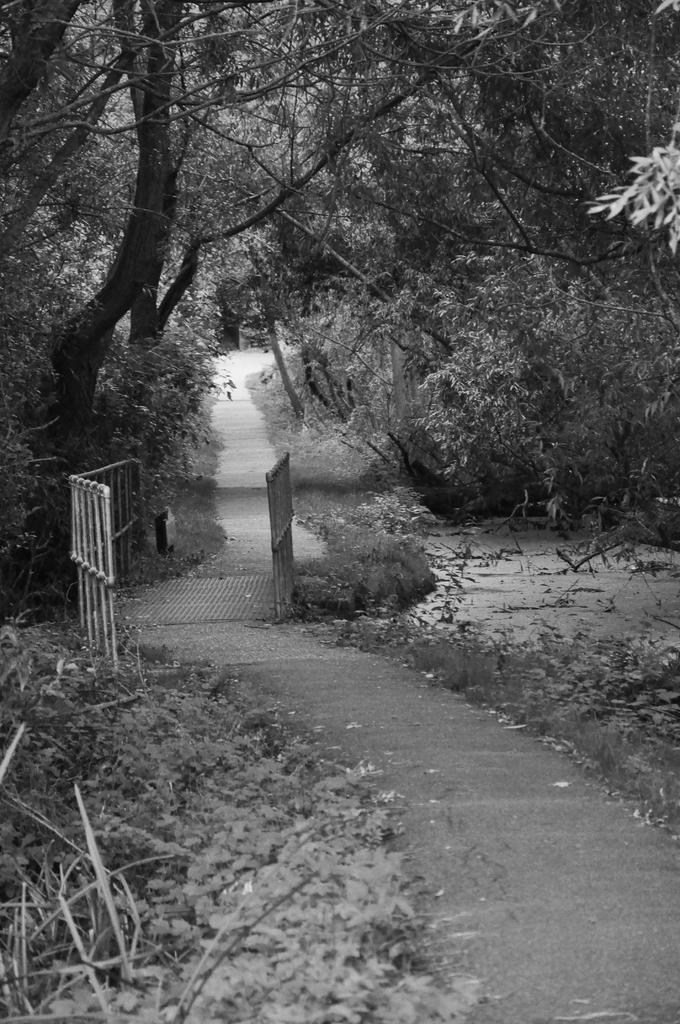Please provide a concise description of this image. In the center of the image we can see trees, plants, grass and fences. 